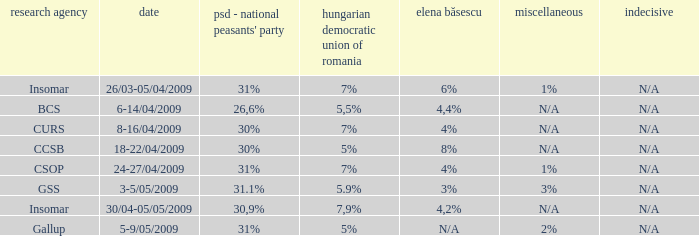What date has the others of 2%? 5-9/05/2009. 